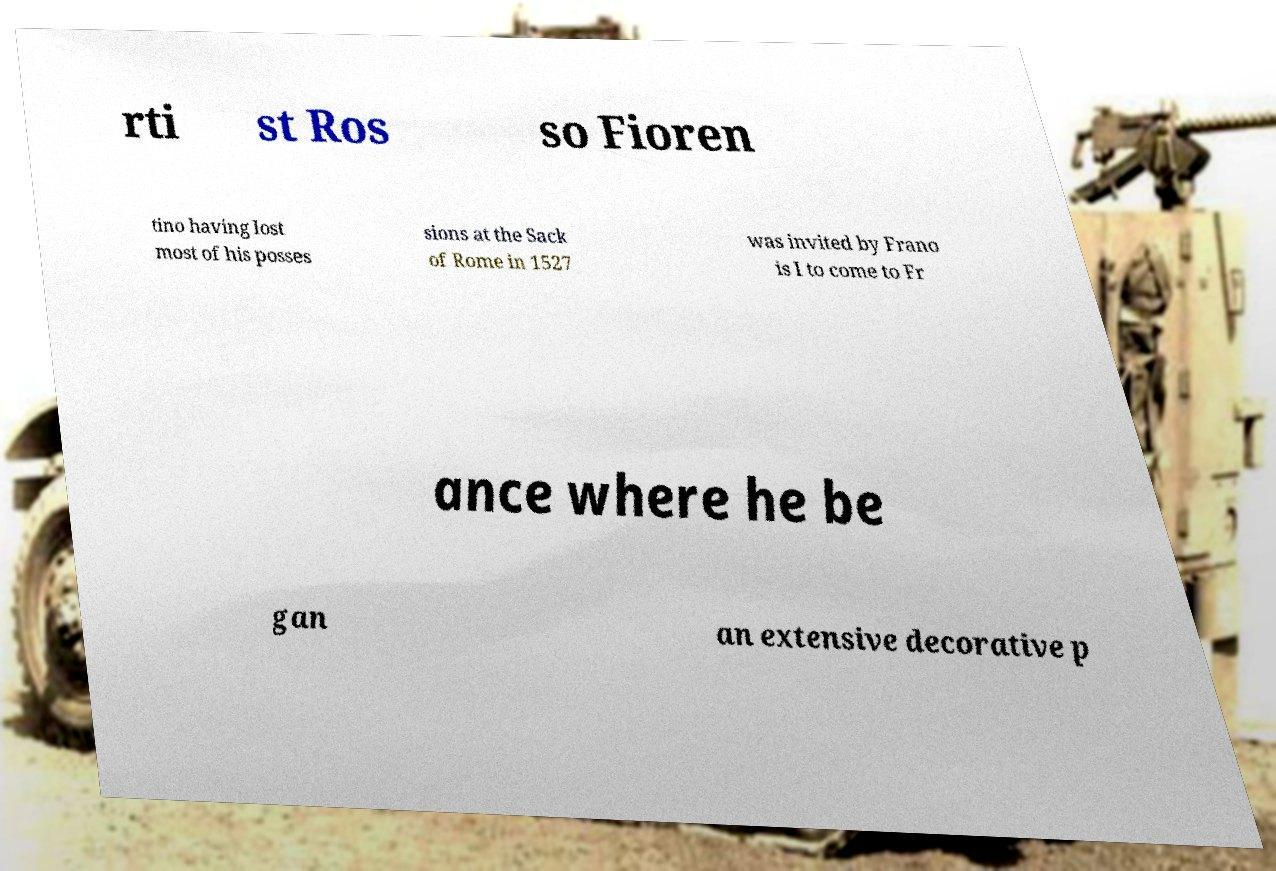For documentation purposes, I need the text within this image transcribed. Could you provide that? rti st Ros so Fioren tino having lost most of his posses sions at the Sack of Rome in 1527 was invited by Frano is I to come to Fr ance where he be gan an extensive decorative p 